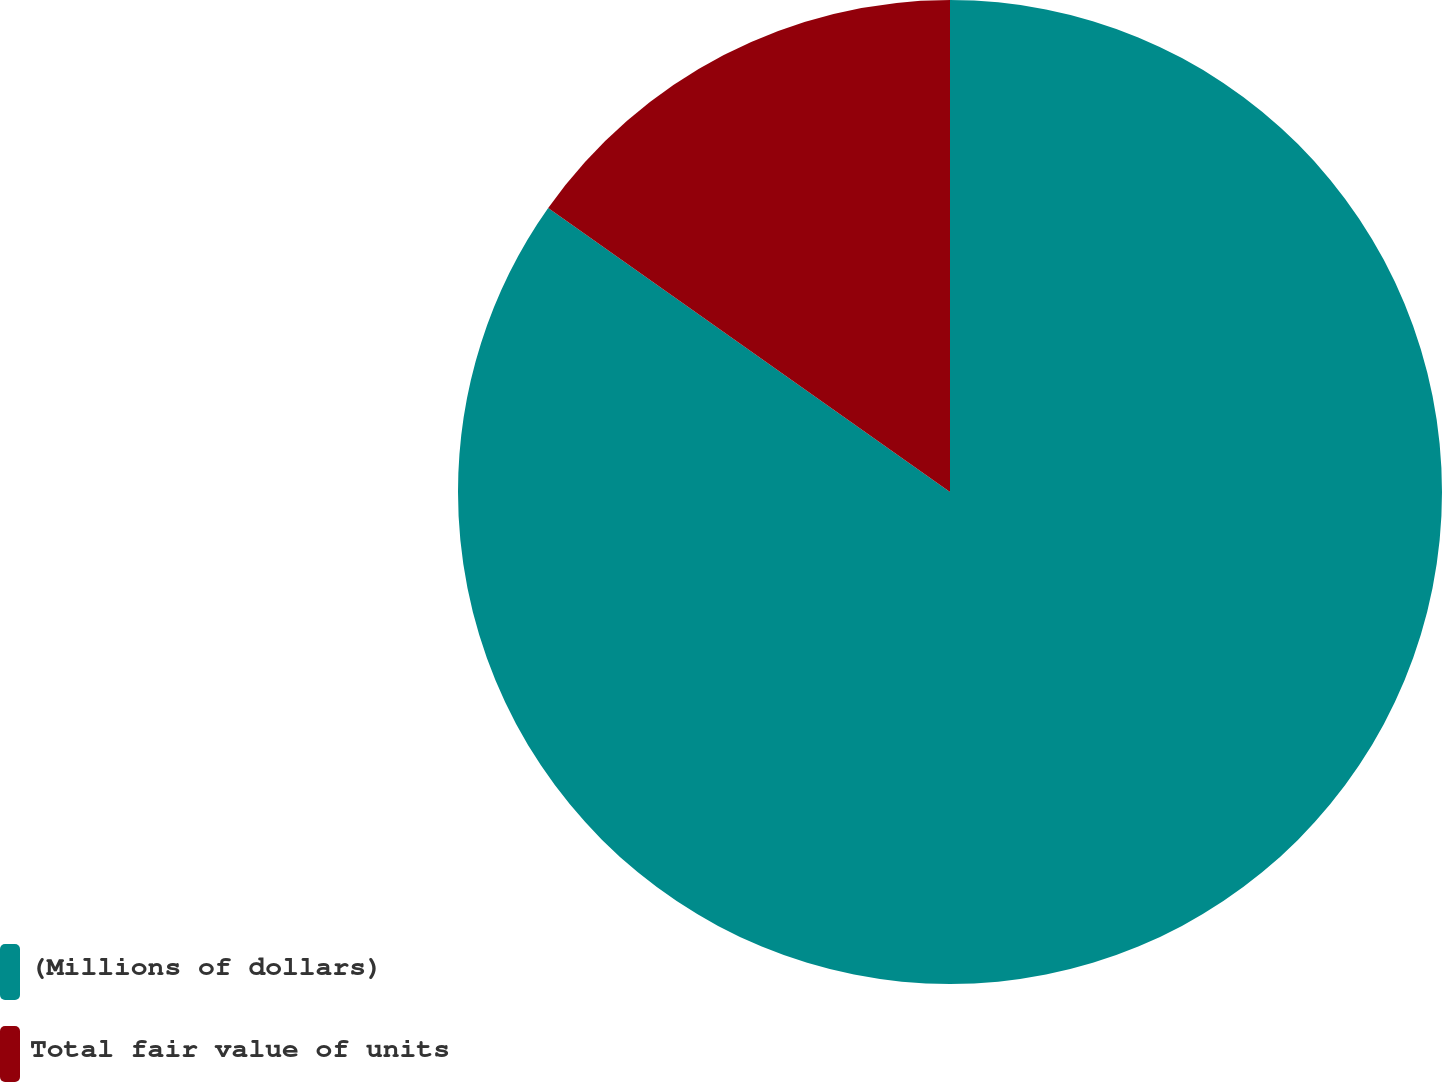<chart> <loc_0><loc_0><loc_500><loc_500><pie_chart><fcel>(Millions of dollars)<fcel>Total fair value of units<nl><fcel>84.79%<fcel>15.21%<nl></chart> 